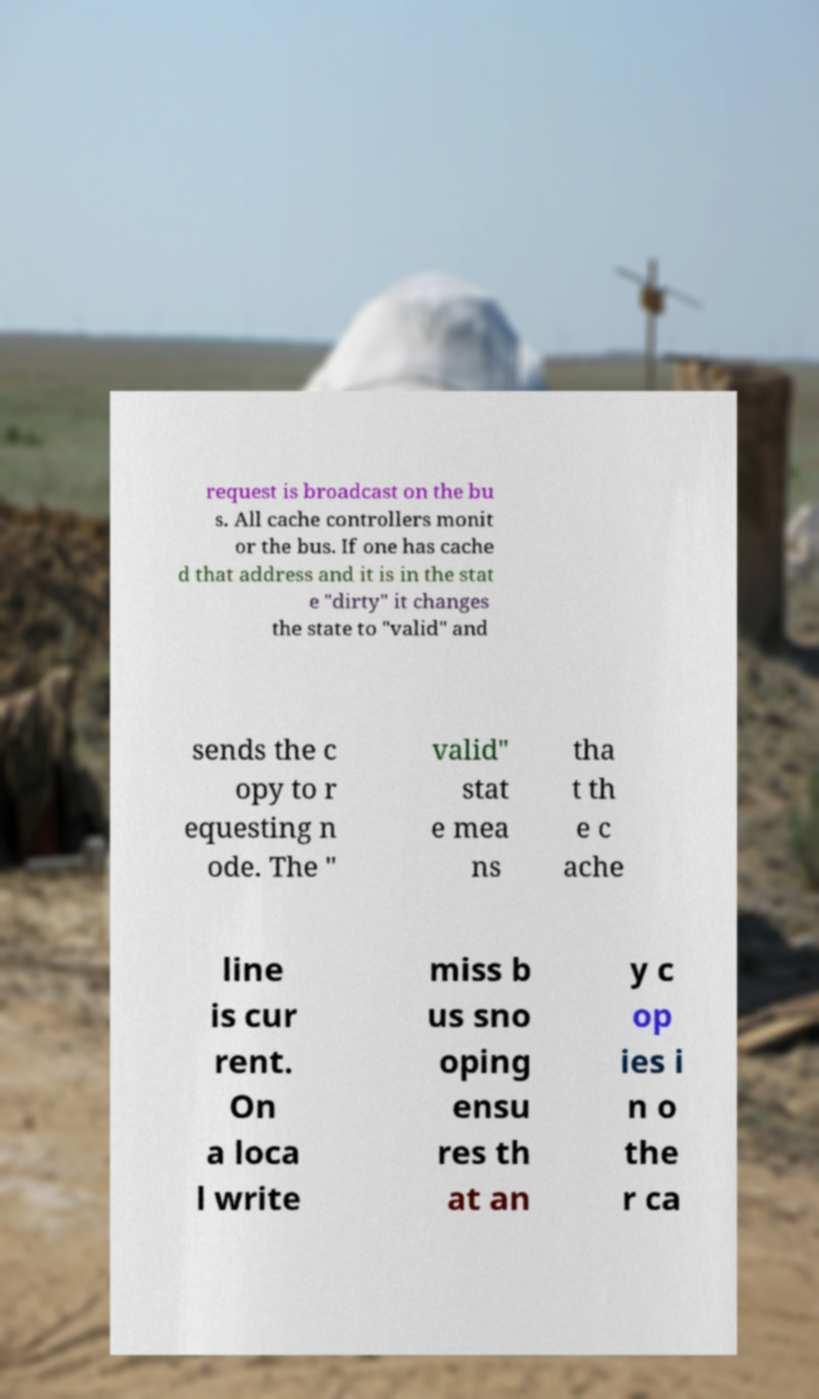Can you accurately transcribe the text from the provided image for me? request is broadcast on the bu s. All cache controllers monit or the bus. If one has cache d that address and it is in the stat e "dirty" it changes the state to "valid" and sends the c opy to r equesting n ode. The " valid" stat e mea ns tha t th e c ache line is cur rent. On a loca l write miss b us sno oping ensu res th at an y c op ies i n o the r ca 